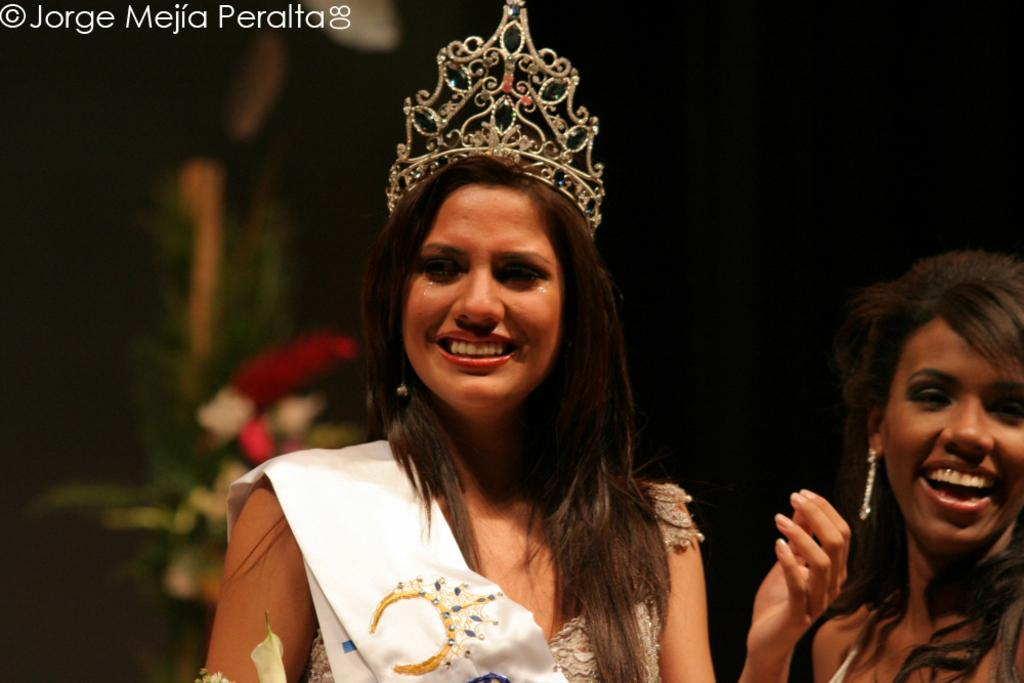How many people are in the image? There are two women in the image. What distinguishes one of the women from the other? One of the women is wearing a crown and sash. What can be seen in the background of the image? There is a bouquet in the background of the image. What type of pizzas are being served in the park in the image? There are no pizzas or park present in the image; it features two women, one of whom is wearing a crown and sash, and a bouquet in the background. 